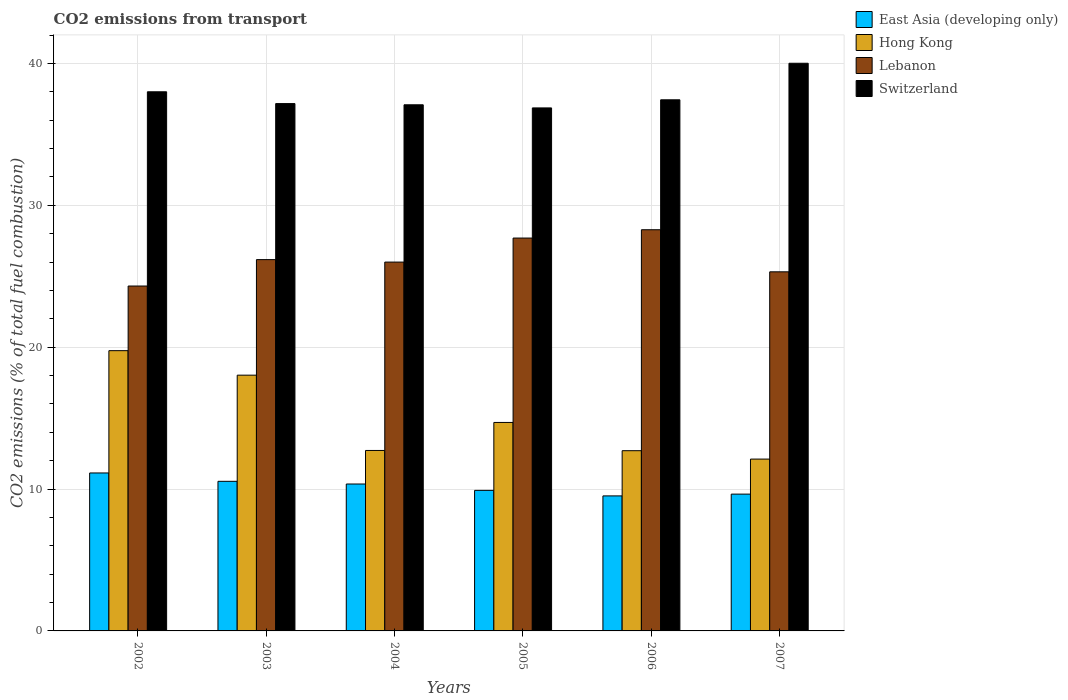How many different coloured bars are there?
Give a very brief answer. 4. How many groups of bars are there?
Offer a very short reply. 6. Are the number of bars on each tick of the X-axis equal?
Offer a very short reply. Yes. How many bars are there on the 5th tick from the left?
Offer a terse response. 4. In how many cases, is the number of bars for a given year not equal to the number of legend labels?
Offer a very short reply. 0. What is the total CO2 emitted in Hong Kong in 2002?
Your response must be concise. 19.75. Across all years, what is the maximum total CO2 emitted in Switzerland?
Make the answer very short. 40.01. Across all years, what is the minimum total CO2 emitted in Hong Kong?
Make the answer very short. 12.11. In which year was the total CO2 emitted in Lebanon minimum?
Provide a succinct answer. 2002. What is the total total CO2 emitted in Lebanon in the graph?
Make the answer very short. 157.77. What is the difference between the total CO2 emitted in Hong Kong in 2006 and that in 2007?
Give a very brief answer. 0.59. What is the difference between the total CO2 emitted in Hong Kong in 2003 and the total CO2 emitted in East Asia (developing only) in 2002?
Ensure brevity in your answer.  6.89. What is the average total CO2 emitted in Lebanon per year?
Provide a short and direct response. 26.29. In the year 2006, what is the difference between the total CO2 emitted in Lebanon and total CO2 emitted in Switzerland?
Offer a terse response. -9.16. What is the ratio of the total CO2 emitted in Hong Kong in 2003 to that in 2006?
Your response must be concise. 1.42. Is the total CO2 emitted in Switzerland in 2004 less than that in 2005?
Offer a terse response. No. What is the difference between the highest and the second highest total CO2 emitted in East Asia (developing only)?
Your response must be concise. 0.59. What is the difference between the highest and the lowest total CO2 emitted in East Asia (developing only)?
Make the answer very short. 1.62. In how many years, is the total CO2 emitted in Hong Kong greater than the average total CO2 emitted in Hong Kong taken over all years?
Your answer should be very brief. 2. Is the sum of the total CO2 emitted in Hong Kong in 2002 and 2005 greater than the maximum total CO2 emitted in East Asia (developing only) across all years?
Provide a succinct answer. Yes. Is it the case that in every year, the sum of the total CO2 emitted in Lebanon and total CO2 emitted in Switzerland is greater than the sum of total CO2 emitted in East Asia (developing only) and total CO2 emitted in Hong Kong?
Offer a terse response. No. What does the 2nd bar from the left in 2004 represents?
Provide a succinct answer. Hong Kong. What does the 1st bar from the right in 2003 represents?
Provide a succinct answer. Switzerland. How many bars are there?
Your response must be concise. 24. Are all the bars in the graph horizontal?
Make the answer very short. No. Are the values on the major ticks of Y-axis written in scientific E-notation?
Offer a terse response. No. Does the graph contain grids?
Give a very brief answer. Yes. What is the title of the graph?
Provide a succinct answer. CO2 emissions from transport. Does "Faeroe Islands" appear as one of the legend labels in the graph?
Make the answer very short. No. What is the label or title of the Y-axis?
Your answer should be very brief. CO2 emissions (% of total fuel combustion). What is the CO2 emissions (% of total fuel combustion) of East Asia (developing only) in 2002?
Keep it short and to the point. 11.13. What is the CO2 emissions (% of total fuel combustion) of Hong Kong in 2002?
Offer a terse response. 19.75. What is the CO2 emissions (% of total fuel combustion) in Lebanon in 2002?
Your response must be concise. 24.31. What is the CO2 emissions (% of total fuel combustion) of Switzerland in 2002?
Make the answer very short. 38. What is the CO2 emissions (% of total fuel combustion) in East Asia (developing only) in 2003?
Keep it short and to the point. 10.55. What is the CO2 emissions (% of total fuel combustion) of Hong Kong in 2003?
Provide a short and direct response. 18.03. What is the CO2 emissions (% of total fuel combustion) of Lebanon in 2003?
Ensure brevity in your answer.  26.17. What is the CO2 emissions (% of total fuel combustion) of Switzerland in 2003?
Make the answer very short. 37.17. What is the CO2 emissions (% of total fuel combustion) in East Asia (developing only) in 2004?
Give a very brief answer. 10.36. What is the CO2 emissions (% of total fuel combustion) of Hong Kong in 2004?
Your answer should be compact. 12.72. What is the CO2 emissions (% of total fuel combustion) in Lebanon in 2004?
Your response must be concise. 26. What is the CO2 emissions (% of total fuel combustion) of Switzerland in 2004?
Ensure brevity in your answer.  37.09. What is the CO2 emissions (% of total fuel combustion) of East Asia (developing only) in 2005?
Your answer should be compact. 9.91. What is the CO2 emissions (% of total fuel combustion) of Hong Kong in 2005?
Make the answer very short. 14.7. What is the CO2 emissions (% of total fuel combustion) of Lebanon in 2005?
Keep it short and to the point. 27.69. What is the CO2 emissions (% of total fuel combustion) in Switzerland in 2005?
Your answer should be compact. 36.87. What is the CO2 emissions (% of total fuel combustion) in East Asia (developing only) in 2006?
Give a very brief answer. 9.52. What is the CO2 emissions (% of total fuel combustion) in Hong Kong in 2006?
Keep it short and to the point. 12.7. What is the CO2 emissions (% of total fuel combustion) of Lebanon in 2006?
Provide a succinct answer. 28.28. What is the CO2 emissions (% of total fuel combustion) in Switzerland in 2006?
Provide a short and direct response. 37.44. What is the CO2 emissions (% of total fuel combustion) of East Asia (developing only) in 2007?
Make the answer very short. 9.64. What is the CO2 emissions (% of total fuel combustion) in Hong Kong in 2007?
Your answer should be very brief. 12.11. What is the CO2 emissions (% of total fuel combustion) in Lebanon in 2007?
Ensure brevity in your answer.  25.31. What is the CO2 emissions (% of total fuel combustion) of Switzerland in 2007?
Give a very brief answer. 40.01. Across all years, what is the maximum CO2 emissions (% of total fuel combustion) of East Asia (developing only)?
Offer a terse response. 11.13. Across all years, what is the maximum CO2 emissions (% of total fuel combustion) in Hong Kong?
Ensure brevity in your answer.  19.75. Across all years, what is the maximum CO2 emissions (% of total fuel combustion) in Lebanon?
Make the answer very short. 28.28. Across all years, what is the maximum CO2 emissions (% of total fuel combustion) in Switzerland?
Your response must be concise. 40.01. Across all years, what is the minimum CO2 emissions (% of total fuel combustion) in East Asia (developing only)?
Make the answer very short. 9.52. Across all years, what is the minimum CO2 emissions (% of total fuel combustion) of Hong Kong?
Your answer should be very brief. 12.11. Across all years, what is the minimum CO2 emissions (% of total fuel combustion) of Lebanon?
Your answer should be compact. 24.31. Across all years, what is the minimum CO2 emissions (% of total fuel combustion) in Switzerland?
Provide a short and direct response. 36.87. What is the total CO2 emissions (% of total fuel combustion) of East Asia (developing only) in the graph?
Make the answer very short. 61.1. What is the total CO2 emissions (% of total fuel combustion) in Hong Kong in the graph?
Offer a terse response. 90.02. What is the total CO2 emissions (% of total fuel combustion) of Lebanon in the graph?
Provide a short and direct response. 157.77. What is the total CO2 emissions (% of total fuel combustion) of Switzerland in the graph?
Offer a terse response. 226.58. What is the difference between the CO2 emissions (% of total fuel combustion) of East Asia (developing only) in 2002 and that in 2003?
Make the answer very short. 0.59. What is the difference between the CO2 emissions (% of total fuel combustion) in Hong Kong in 2002 and that in 2003?
Keep it short and to the point. 1.73. What is the difference between the CO2 emissions (% of total fuel combustion) in Lebanon in 2002 and that in 2003?
Make the answer very short. -1.86. What is the difference between the CO2 emissions (% of total fuel combustion) in Switzerland in 2002 and that in 2003?
Provide a succinct answer. 0.83. What is the difference between the CO2 emissions (% of total fuel combustion) of East Asia (developing only) in 2002 and that in 2004?
Provide a succinct answer. 0.78. What is the difference between the CO2 emissions (% of total fuel combustion) in Hong Kong in 2002 and that in 2004?
Your answer should be compact. 7.03. What is the difference between the CO2 emissions (% of total fuel combustion) of Lebanon in 2002 and that in 2004?
Your answer should be very brief. -1.69. What is the difference between the CO2 emissions (% of total fuel combustion) in Switzerland in 2002 and that in 2004?
Give a very brief answer. 0.92. What is the difference between the CO2 emissions (% of total fuel combustion) of East Asia (developing only) in 2002 and that in 2005?
Your response must be concise. 1.23. What is the difference between the CO2 emissions (% of total fuel combustion) of Hong Kong in 2002 and that in 2005?
Offer a terse response. 5.06. What is the difference between the CO2 emissions (% of total fuel combustion) in Lebanon in 2002 and that in 2005?
Your answer should be very brief. -3.38. What is the difference between the CO2 emissions (% of total fuel combustion) in Switzerland in 2002 and that in 2005?
Your answer should be compact. 1.14. What is the difference between the CO2 emissions (% of total fuel combustion) in East Asia (developing only) in 2002 and that in 2006?
Keep it short and to the point. 1.62. What is the difference between the CO2 emissions (% of total fuel combustion) in Hong Kong in 2002 and that in 2006?
Offer a terse response. 7.05. What is the difference between the CO2 emissions (% of total fuel combustion) in Lebanon in 2002 and that in 2006?
Provide a succinct answer. -3.97. What is the difference between the CO2 emissions (% of total fuel combustion) of Switzerland in 2002 and that in 2006?
Ensure brevity in your answer.  0.57. What is the difference between the CO2 emissions (% of total fuel combustion) in East Asia (developing only) in 2002 and that in 2007?
Your answer should be compact. 1.49. What is the difference between the CO2 emissions (% of total fuel combustion) in Hong Kong in 2002 and that in 2007?
Give a very brief answer. 7.64. What is the difference between the CO2 emissions (% of total fuel combustion) in Lebanon in 2002 and that in 2007?
Your answer should be very brief. -1. What is the difference between the CO2 emissions (% of total fuel combustion) of Switzerland in 2002 and that in 2007?
Make the answer very short. -2.01. What is the difference between the CO2 emissions (% of total fuel combustion) of East Asia (developing only) in 2003 and that in 2004?
Your response must be concise. 0.19. What is the difference between the CO2 emissions (% of total fuel combustion) in Hong Kong in 2003 and that in 2004?
Ensure brevity in your answer.  5.31. What is the difference between the CO2 emissions (% of total fuel combustion) of Lebanon in 2003 and that in 2004?
Offer a very short reply. 0.17. What is the difference between the CO2 emissions (% of total fuel combustion) in Switzerland in 2003 and that in 2004?
Ensure brevity in your answer.  0.09. What is the difference between the CO2 emissions (% of total fuel combustion) in East Asia (developing only) in 2003 and that in 2005?
Keep it short and to the point. 0.64. What is the difference between the CO2 emissions (% of total fuel combustion) in Hong Kong in 2003 and that in 2005?
Provide a succinct answer. 3.33. What is the difference between the CO2 emissions (% of total fuel combustion) in Lebanon in 2003 and that in 2005?
Your response must be concise. -1.52. What is the difference between the CO2 emissions (% of total fuel combustion) in Switzerland in 2003 and that in 2005?
Your answer should be very brief. 0.3. What is the difference between the CO2 emissions (% of total fuel combustion) of East Asia (developing only) in 2003 and that in 2006?
Give a very brief answer. 1.03. What is the difference between the CO2 emissions (% of total fuel combustion) of Hong Kong in 2003 and that in 2006?
Your answer should be very brief. 5.32. What is the difference between the CO2 emissions (% of total fuel combustion) of Lebanon in 2003 and that in 2006?
Offer a terse response. -2.11. What is the difference between the CO2 emissions (% of total fuel combustion) of Switzerland in 2003 and that in 2006?
Give a very brief answer. -0.27. What is the difference between the CO2 emissions (% of total fuel combustion) of East Asia (developing only) in 2003 and that in 2007?
Your response must be concise. 0.9. What is the difference between the CO2 emissions (% of total fuel combustion) in Hong Kong in 2003 and that in 2007?
Your response must be concise. 5.91. What is the difference between the CO2 emissions (% of total fuel combustion) in Lebanon in 2003 and that in 2007?
Offer a terse response. 0.86. What is the difference between the CO2 emissions (% of total fuel combustion) in Switzerland in 2003 and that in 2007?
Give a very brief answer. -2.84. What is the difference between the CO2 emissions (% of total fuel combustion) in East Asia (developing only) in 2004 and that in 2005?
Make the answer very short. 0.45. What is the difference between the CO2 emissions (% of total fuel combustion) of Hong Kong in 2004 and that in 2005?
Ensure brevity in your answer.  -1.97. What is the difference between the CO2 emissions (% of total fuel combustion) in Lebanon in 2004 and that in 2005?
Keep it short and to the point. -1.69. What is the difference between the CO2 emissions (% of total fuel combustion) of Switzerland in 2004 and that in 2005?
Provide a short and direct response. 0.22. What is the difference between the CO2 emissions (% of total fuel combustion) of East Asia (developing only) in 2004 and that in 2006?
Ensure brevity in your answer.  0.84. What is the difference between the CO2 emissions (% of total fuel combustion) in Hong Kong in 2004 and that in 2006?
Your answer should be compact. 0.02. What is the difference between the CO2 emissions (% of total fuel combustion) of Lebanon in 2004 and that in 2006?
Offer a terse response. -2.28. What is the difference between the CO2 emissions (% of total fuel combustion) of Switzerland in 2004 and that in 2006?
Make the answer very short. -0.35. What is the difference between the CO2 emissions (% of total fuel combustion) of East Asia (developing only) in 2004 and that in 2007?
Keep it short and to the point. 0.71. What is the difference between the CO2 emissions (% of total fuel combustion) in Hong Kong in 2004 and that in 2007?
Your response must be concise. 0.61. What is the difference between the CO2 emissions (% of total fuel combustion) of Lebanon in 2004 and that in 2007?
Your answer should be very brief. 0.69. What is the difference between the CO2 emissions (% of total fuel combustion) in Switzerland in 2004 and that in 2007?
Ensure brevity in your answer.  -2.93. What is the difference between the CO2 emissions (% of total fuel combustion) in East Asia (developing only) in 2005 and that in 2006?
Make the answer very short. 0.39. What is the difference between the CO2 emissions (% of total fuel combustion) in Hong Kong in 2005 and that in 2006?
Your answer should be compact. 1.99. What is the difference between the CO2 emissions (% of total fuel combustion) in Lebanon in 2005 and that in 2006?
Provide a succinct answer. -0.58. What is the difference between the CO2 emissions (% of total fuel combustion) of Switzerland in 2005 and that in 2006?
Your answer should be compact. -0.57. What is the difference between the CO2 emissions (% of total fuel combustion) of East Asia (developing only) in 2005 and that in 2007?
Your response must be concise. 0.26. What is the difference between the CO2 emissions (% of total fuel combustion) in Hong Kong in 2005 and that in 2007?
Make the answer very short. 2.58. What is the difference between the CO2 emissions (% of total fuel combustion) of Lebanon in 2005 and that in 2007?
Your answer should be compact. 2.38. What is the difference between the CO2 emissions (% of total fuel combustion) of Switzerland in 2005 and that in 2007?
Give a very brief answer. -3.15. What is the difference between the CO2 emissions (% of total fuel combustion) in East Asia (developing only) in 2006 and that in 2007?
Your response must be concise. -0.13. What is the difference between the CO2 emissions (% of total fuel combustion) of Hong Kong in 2006 and that in 2007?
Make the answer very short. 0.59. What is the difference between the CO2 emissions (% of total fuel combustion) in Lebanon in 2006 and that in 2007?
Your answer should be very brief. 2.97. What is the difference between the CO2 emissions (% of total fuel combustion) in Switzerland in 2006 and that in 2007?
Ensure brevity in your answer.  -2.58. What is the difference between the CO2 emissions (% of total fuel combustion) of East Asia (developing only) in 2002 and the CO2 emissions (% of total fuel combustion) of Hong Kong in 2003?
Your answer should be compact. -6.89. What is the difference between the CO2 emissions (% of total fuel combustion) of East Asia (developing only) in 2002 and the CO2 emissions (% of total fuel combustion) of Lebanon in 2003?
Your answer should be compact. -15.04. What is the difference between the CO2 emissions (% of total fuel combustion) of East Asia (developing only) in 2002 and the CO2 emissions (% of total fuel combustion) of Switzerland in 2003?
Keep it short and to the point. -26.04. What is the difference between the CO2 emissions (% of total fuel combustion) of Hong Kong in 2002 and the CO2 emissions (% of total fuel combustion) of Lebanon in 2003?
Your response must be concise. -6.42. What is the difference between the CO2 emissions (% of total fuel combustion) of Hong Kong in 2002 and the CO2 emissions (% of total fuel combustion) of Switzerland in 2003?
Provide a succinct answer. -17.42. What is the difference between the CO2 emissions (% of total fuel combustion) in Lebanon in 2002 and the CO2 emissions (% of total fuel combustion) in Switzerland in 2003?
Your answer should be very brief. -12.86. What is the difference between the CO2 emissions (% of total fuel combustion) in East Asia (developing only) in 2002 and the CO2 emissions (% of total fuel combustion) in Hong Kong in 2004?
Keep it short and to the point. -1.59. What is the difference between the CO2 emissions (% of total fuel combustion) of East Asia (developing only) in 2002 and the CO2 emissions (% of total fuel combustion) of Lebanon in 2004?
Your answer should be compact. -14.86. What is the difference between the CO2 emissions (% of total fuel combustion) of East Asia (developing only) in 2002 and the CO2 emissions (% of total fuel combustion) of Switzerland in 2004?
Make the answer very short. -25.95. What is the difference between the CO2 emissions (% of total fuel combustion) in Hong Kong in 2002 and the CO2 emissions (% of total fuel combustion) in Lebanon in 2004?
Offer a very short reply. -6.24. What is the difference between the CO2 emissions (% of total fuel combustion) in Hong Kong in 2002 and the CO2 emissions (% of total fuel combustion) in Switzerland in 2004?
Your response must be concise. -17.33. What is the difference between the CO2 emissions (% of total fuel combustion) of Lebanon in 2002 and the CO2 emissions (% of total fuel combustion) of Switzerland in 2004?
Ensure brevity in your answer.  -12.77. What is the difference between the CO2 emissions (% of total fuel combustion) of East Asia (developing only) in 2002 and the CO2 emissions (% of total fuel combustion) of Hong Kong in 2005?
Provide a short and direct response. -3.56. What is the difference between the CO2 emissions (% of total fuel combustion) of East Asia (developing only) in 2002 and the CO2 emissions (% of total fuel combustion) of Lebanon in 2005?
Provide a short and direct response. -16.56. What is the difference between the CO2 emissions (% of total fuel combustion) in East Asia (developing only) in 2002 and the CO2 emissions (% of total fuel combustion) in Switzerland in 2005?
Keep it short and to the point. -25.73. What is the difference between the CO2 emissions (% of total fuel combustion) in Hong Kong in 2002 and the CO2 emissions (% of total fuel combustion) in Lebanon in 2005?
Provide a short and direct response. -7.94. What is the difference between the CO2 emissions (% of total fuel combustion) in Hong Kong in 2002 and the CO2 emissions (% of total fuel combustion) in Switzerland in 2005?
Give a very brief answer. -17.11. What is the difference between the CO2 emissions (% of total fuel combustion) in Lebanon in 2002 and the CO2 emissions (% of total fuel combustion) in Switzerland in 2005?
Provide a short and direct response. -12.55. What is the difference between the CO2 emissions (% of total fuel combustion) in East Asia (developing only) in 2002 and the CO2 emissions (% of total fuel combustion) in Hong Kong in 2006?
Provide a succinct answer. -1.57. What is the difference between the CO2 emissions (% of total fuel combustion) of East Asia (developing only) in 2002 and the CO2 emissions (% of total fuel combustion) of Lebanon in 2006?
Make the answer very short. -17.14. What is the difference between the CO2 emissions (% of total fuel combustion) of East Asia (developing only) in 2002 and the CO2 emissions (% of total fuel combustion) of Switzerland in 2006?
Provide a short and direct response. -26.3. What is the difference between the CO2 emissions (% of total fuel combustion) of Hong Kong in 2002 and the CO2 emissions (% of total fuel combustion) of Lebanon in 2006?
Provide a short and direct response. -8.52. What is the difference between the CO2 emissions (% of total fuel combustion) in Hong Kong in 2002 and the CO2 emissions (% of total fuel combustion) in Switzerland in 2006?
Make the answer very short. -17.68. What is the difference between the CO2 emissions (% of total fuel combustion) in Lebanon in 2002 and the CO2 emissions (% of total fuel combustion) in Switzerland in 2006?
Offer a very short reply. -13.13. What is the difference between the CO2 emissions (% of total fuel combustion) of East Asia (developing only) in 2002 and the CO2 emissions (% of total fuel combustion) of Hong Kong in 2007?
Provide a succinct answer. -0.98. What is the difference between the CO2 emissions (% of total fuel combustion) in East Asia (developing only) in 2002 and the CO2 emissions (% of total fuel combustion) in Lebanon in 2007?
Keep it short and to the point. -14.18. What is the difference between the CO2 emissions (% of total fuel combustion) of East Asia (developing only) in 2002 and the CO2 emissions (% of total fuel combustion) of Switzerland in 2007?
Your answer should be very brief. -28.88. What is the difference between the CO2 emissions (% of total fuel combustion) of Hong Kong in 2002 and the CO2 emissions (% of total fuel combustion) of Lebanon in 2007?
Offer a very short reply. -5.56. What is the difference between the CO2 emissions (% of total fuel combustion) of Hong Kong in 2002 and the CO2 emissions (% of total fuel combustion) of Switzerland in 2007?
Your response must be concise. -20.26. What is the difference between the CO2 emissions (% of total fuel combustion) of Lebanon in 2002 and the CO2 emissions (% of total fuel combustion) of Switzerland in 2007?
Your response must be concise. -15.7. What is the difference between the CO2 emissions (% of total fuel combustion) of East Asia (developing only) in 2003 and the CO2 emissions (% of total fuel combustion) of Hong Kong in 2004?
Your answer should be very brief. -2.18. What is the difference between the CO2 emissions (% of total fuel combustion) of East Asia (developing only) in 2003 and the CO2 emissions (% of total fuel combustion) of Lebanon in 2004?
Provide a short and direct response. -15.45. What is the difference between the CO2 emissions (% of total fuel combustion) in East Asia (developing only) in 2003 and the CO2 emissions (% of total fuel combustion) in Switzerland in 2004?
Give a very brief answer. -26.54. What is the difference between the CO2 emissions (% of total fuel combustion) of Hong Kong in 2003 and the CO2 emissions (% of total fuel combustion) of Lebanon in 2004?
Provide a succinct answer. -7.97. What is the difference between the CO2 emissions (% of total fuel combustion) of Hong Kong in 2003 and the CO2 emissions (% of total fuel combustion) of Switzerland in 2004?
Your answer should be compact. -19.06. What is the difference between the CO2 emissions (% of total fuel combustion) of Lebanon in 2003 and the CO2 emissions (% of total fuel combustion) of Switzerland in 2004?
Keep it short and to the point. -10.91. What is the difference between the CO2 emissions (% of total fuel combustion) in East Asia (developing only) in 2003 and the CO2 emissions (% of total fuel combustion) in Hong Kong in 2005?
Make the answer very short. -4.15. What is the difference between the CO2 emissions (% of total fuel combustion) in East Asia (developing only) in 2003 and the CO2 emissions (% of total fuel combustion) in Lebanon in 2005?
Provide a succinct answer. -17.15. What is the difference between the CO2 emissions (% of total fuel combustion) in East Asia (developing only) in 2003 and the CO2 emissions (% of total fuel combustion) in Switzerland in 2005?
Offer a very short reply. -26.32. What is the difference between the CO2 emissions (% of total fuel combustion) in Hong Kong in 2003 and the CO2 emissions (% of total fuel combustion) in Lebanon in 2005?
Give a very brief answer. -9.67. What is the difference between the CO2 emissions (% of total fuel combustion) in Hong Kong in 2003 and the CO2 emissions (% of total fuel combustion) in Switzerland in 2005?
Offer a terse response. -18.84. What is the difference between the CO2 emissions (% of total fuel combustion) in Lebanon in 2003 and the CO2 emissions (% of total fuel combustion) in Switzerland in 2005?
Give a very brief answer. -10.69. What is the difference between the CO2 emissions (% of total fuel combustion) of East Asia (developing only) in 2003 and the CO2 emissions (% of total fuel combustion) of Hong Kong in 2006?
Your response must be concise. -2.16. What is the difference between the CO2 emissions (% of total fuel combustion) of East Asia (developing only) in 2003 and the CO2 emissions (% of total fuel combustion) of Lebanon in 2006?
Your answer should be compact. -17.73. What is the difference between the CO2 emissions (% of total fuel combustion) of East Asia (developing only) in 2003 and the CO2 emissions (% of total fuel combustion) of Switzerland in 2006?
Offer a very short reply. -26.89. What is the difference between the CO2 emissions (% of total fuel combustion) in Hong Kong in 2003 and the CO2 emissions (% of total fuel combustion) in Lebanon in 2006?
Offer a very short reply. -10.25. What is the difference between the CO2 emissions (% of total fuel combustion) in Hong Kong in 2003 and the CO2 emissions (% of total fuel combustion) in Switzerland in 2006?
Make the answer very short. -19.41. What is the difference between the CO2 emissions (% of total fuel combustion) of Lebanon in 2003 and the CO2 emissions (% of total fuel combustion) of Switzerland in 2006?
Your response must be concise. -11.26. What is the difference between the CO2 emissions (% of total fuel combustion) in East Asia (developing only) in 2003 and the CO2 emissions (% of total fuel combustion) in Hong Kong in 2007?
Make the answer very short. -1.57. What is the difference between the CO2 emissions (% of total fuel combustion) in East Asia (developing only) in 2003 and the CO2 emissions (% of total fuel combustion) in Lebanon in 2007?
Give a very brief answer. -14.77. What is the difference between the CO2 emissions (% of total fuel combustion) of East Asia (developing only) in 2003 and the CO2 emissions (% of total fuel combustion) of Switzerland in 2007?
Provide a succinct answer. -29.47. What is the difference between the CO2 emissions (% of total fuel combustion) in Hong Kong in 2003 and the CO2 emissions (% of total fuel combustion) in Lebanon in 2007?
Your answer should be very brief. -7.28. What is the difference between the CO2 emissions (% of total fuel combustion) in Hong Kong in 2003 and the CO2 emissions (% of total fuel combustion) in Switzerland in 2007?
Your answer should be very brief. -21.99. What is the difference between the CO2 emissions (% of total fuel combustion) of Lebanon in 2003 and the CO2 emissions (% of total fuel combustion) of Switzerland in 2007?
Offer a terse response. -13.84. What is the difference between the CO2 emissions (% of total fuel combustion) in East Asia (developing only) in 2004 and the CO2 emissions (% of total fuel combustion) in Hong Kong in 2005?
Offer a terse response. -4.34. What is the difference between the CO2 emissions (% of total fuel combustion) of East Asia (developing only) in 2004 and the CO2 emissions (% of total fuel combustion) of Lebanon in 2005?
Offer a terse response. -17.34. What is the difference between the CO2 emissions (% of total fuel combustion) in East Asia (developing only) in 2004 and the CO2 emissions (% of total fuel combustion) in Switzerland in 2005?
Offer a very short reply. -26.51. What is the difference between the CO2 emissions (% of total fuel combustion) in Hong Kong in 2004 and the CO2 emissions (% of total fuel combustion) in Lebanon in 2005?
Your answer should be compact. -14.97. What is the difference between the CO2 emissions (% of total fuel combustion) of Hong Kong in 2004 and the CO2 emissions (% of total fuel combustion) of Switzerland in 2005?
Your response must be concise. -24.15. What is the difference between the CO2 emissions (% of total fuel combustion) in Lebanon in 2004 and the CO2 emissions (% of total fuel combustion) in Switzerland in 2005?
Ensure brevity in your answer.  -10.87. What is the difference between the CO2 emissions (% of total fuel combustion) of East Asia (developing only) in 2004 and the CO2 emissions (% of total fuel combustion) of Hong Kong in 2006?
Your answer should be very brief. -2.35. What is the difference between the CO2 emissions (% of total fuel combustion) of East Asia (developing only) in 2004 and the CO2 emissions (% of total fuel combustion) of Lebanon in 2006?
Make the answer very short. -17.92. What is the difference between the CO2 emissions (% of total fuel combustion) of East Asia (developing only) in 2004 and the CO2 emissions (% of total fuel combustion) of Switzerland in 2006?
Offer a terse response. -27.08. What is the difference between the CO2 emissions (% of total fuel combustion) in Hong Kong in 2004 and the CO2 emissions (% of total fuel combustion) in Lebanon in 2006?
Provide a short and direct response. -15.56. What is the difference between the CO2 emissions (% of total fuel combustion) in Hong Kong in 2004 and the CO2 emissions (% of total fuel combustion) in Switzerland in 2006?
Offer a terse response. -24.72. What is the difference between the CO2 emissions (% of total fuel combustion) in Lebanon in 2004 and the CO2 emissions (% of total fuel combustion) in Switzerland in 2006?
Provide a short and direct response. -11.44. What is the difference between the CO2 emissions (% of total fuel combustion) of East Asia (developing only) in 2004 and the CO2 emissions (% of total fuel combustion) of Hong Kong in 2007?
Offer a terse response. -1.76. What is the difference between the CO2 emissions (% of total fuel combustion) in East Asia (developing only) in 2004 and the CO2 emissions (% of total fuel combustion) in Lebanon in 2007?
Give a very brief answer. -14.96. What is the difference between the CO2 emissions (% of total fuel combustion) in East Asia (developing only) in 2004 and the CO2 emissions (% of total fuel combustion) in Switzerland in 2007?
Your answer should be compact. -29.66. What is the difference between the CO2 emissions (% of total fuel combustion) of Hong Kong in 2004 and the CO2 emissions (% of total fuel combustion) of Lebanon in 2007?
Make the answer very short. -12.59. What is the difference between the CO2 emissions (% of total fuel combustion) of Hong Kong in 2004 and the CO2 emissions (% of total fuel combustion) of Switzerland in 2007?
Your response must be concise. -27.29. What is the difference between the CO2 emissions (% of total fuel combustion) in Lebanon in 2004 and the CO2 emissions (% of total fuel combustion) in Switzerland in 2007?
Provide a succinct answer. -14.02. What is the difference between the CO2 emissions (% of total fuel combustion) of East Asia (developing only) in 2005 and the CO2 emissions (% of total fuel combustion) of Hong Kong in 2006?
Offer a very short reply. -2.8. What is the difference between the CO2 emissions (% of total fuel combustion) of East Asia (developing only) in 2005 and the CO2 emissions (% of total fuel combustion) of Lebanon in 2006?
Make the answer very short. -18.37. What is the difference between the CO2 emissions (% of total fuel combustion) in East Asia (developing only) in 2005 and the CO2 emissions (% of total fuel combustion) in Switzerland in 2006?
Offer a terse response. -27.53. What is the difference between the CO2 emissions (% of total fuel combustion) of Hong Kong in 2005 and the CO2 emissions (% of total fuel combustion) of Lebanon in 2006?
Your answer should be very brief. -13.58. What is the difference between the CO2 emissions (% of total fuel combustion) in Hong Kong in 2005 and the CO2 emissions (% of total fuel combustion) in Switzerland in 2006?
Provide a succinct answer. -22.74. What is the difference between the CO2 emissions (% of total fuel combustion) in Lebanon in 2005 and the CO2 emissions (% of total fuel combustion) in Switzerland in 2006?
Keep it short and to the point. -9.74. What is the difference between the CO2 emissions (% of total fuel combustion) in East Asia (developing only) in 2005 and the CO2 emissions (% of total fuel combustion) in Hong Kong in 2007?
Provide a short and direct response. -2.21. What is the difference between the CO2 emissions (% of total fuel combustion) of East Asia (developing only) in 2005 and the CO2 emissions (% of total fuel combustion) of Lebanon in 2007?
Your response must be concise. -15.4. What is the difference between the CO2 emissions (% of total fuel combustion) of East Asia (developing only) in 2005 and the CO2 emissions (% of total fuel combustion) of Switzerland in 2007?
Ensure brevity in your answer.  -30.11. What is the difference between the CO2 emissions (% of total fuel combustion) of Hong Kong in 2005 and the CO2 emissions (% of total fuel combustion) of Lebanon in 2007?
Provide a succinct answer. -10.62. What is the difference between the CO2 emissions (% of total fuel combustion) of Hong Kong in 2005 and the CO2 emissions (% of total fuel combustion) of Switzerland in 2007?
Give a very brief answer. -25.32. What is the difference between the CO2 emissions (% of total fuel combustion) in Lebanon in 2005 and the CO2 emissions (% of total fuel combustion) in Switzerland in 2007?
Make the answer very short. -12.32. What is the difference between the CO2 emissions (% of total fuel combustion) of East Asia (developing only) in 2006 and the CO2 emissions (% of total fuel combustion) of Hong Kong in 2007?
Make the answer very short. -2.6. What is the difference between the CO2 emissions (% of total fuel combustion) in East Asia (developing only) in 2006 and the CO2 emissions (% of total fuel combustion) in Lebanon in 2007?
Ensure brevity in your answer.  -15.79. What is the difference between the CO2 emissions (% of total fuel combustion) of East Asia (developing only) in 2006 and the CO2 emissions (% of total fuel combustion) of Switzerland in 2007?
Your answer should be very brief. -30.5. What is the difference between the CO2 emissions (% of total fuel combustion) in Hong Kong in 2006 and the CO2 emissions (% of total fuel combustion) in Lebanon in 2007?
Keep it short and to the point. -12.61. What is the difference between the CO2 emissions (% of total fuel combustion) of Hong Kong in 2006 and the CO2 emissions (% of total fuel combustion) of Switzerland in 2007?
Offer a terse response. -27.31. What is the difference between the CO2 emissions (% of total fuel combustion) in Lebanon in 2006 and the CO2 emissions (% of total fuel combustion) in Switzerland in 2007?
Your response must be concise. -11.74. What is the average CO2 emissions (% of total fuel combustion) of East Asia (developing only) per year?
Offer a very short reply. 10.18. What is the average CO2 emissions (% of total fuel combustion) of Hong Kong per year?
Your response must be concise. 15. What is the average CO2 emissions (% of total fuel combustion) in Lebanon per year?
Provide a succinct answer. 26.29. What is the average CO2 emissions (% of total fuel combustion) of Switzerland per year?
Your answer should be compact. 37.76. In the year 2002, what is the difference between the CO2 emissions (% of total fuel combustion) in East Asia (developing only) and CO2 emissions (% of total fuel combustion) in Hong Kong?
Provide a short and direct response. -8.62. In the year 2002, what is the difference between the CO2 emissions (% of total fuel combustion) in East Asia (developing only) and CO2 emissions (% of total fuel combustion) in Lebanon?
Offer a very short reply. -13.18. In the year 2002, what is the difference between the CO2 emissions (% of total fuel combustion) of East Asia (developing only) and CO2 emissions (% of total fuel combustion) of Switzerland?
Your answer should be compact. -26.87. In the year 2002, what is the difference between the CO2 emissions (% of total fuel combustion) in Hong Kong and CO2 emissions (% of total fuel combustion) in Lebanon?
Your answer should be compact. -4.56. In the year 2002, what is the difference between the CO2 emissions (% of total fuel combustion) of Hong Kong and CO2 emissions (% of total fuel combustion) of Switzerland?
Provide a succinct answer. -18.25. In the year 2002, what is the difference between the CO2 emissions (% of total fuel combustion) in Lebanon and CO2 emissions (% of total fuel combustion) in Switzerland?
Keep it short and to the point. -13.69. In the year 2003, what is the difference between the CO2 emissions (% of total fuel combustion) of East Asia (developing only) and CO2 emissions (% of total fuel combustion) of Hong Kong?
Your answer should be very brief. -7.48. In the year 2003, what is the difference between the CO2 emissions (% of total fuel combustion) of East Asia (developing only) and CO2 emissions (% of total fuel combustion) of Lebanon?
Keep it short and to the point. -15.63. In the year 2003, what is the difference between the CO2 emissions (% of total fuel combustion) of East Asia (developing only) and CO2 emissions (% of total fuel combustion) of Switzerland?
Give a very brief answer. -26.63. In the year 2003, what is the difference between the CO2 emissions (% of total fuel combustion) in Hong Kong and CO2 emissions (% of total fuel combustion) in Lebanon?
Offer a terse response. -8.15. In the year 2003, what is the difference between the CO2 emissions (% of total fuel combustion) of Hong Kong and CO2 emissions (% of total fuel combustion) of Switzerland?
Offer a very short reply. -19.14. In the year 2003, what is the difference between the CO2 emissions (% of total fuel combustion) of Lebanon and CO2 emissions (% of total fuel combustion) of Switzerland?
Provide a short and direct response. -11. In the year 2004, what is the difference between the CO2 emissions (% of total fuel combustion) of East Asia (developing only) and CO2 emissions (% of total fuel combustion) of Hong Kong?
Provide a short and direct response. -2.36. In the year 2004, what is the difference between the CO2 emissions (% of total fuel combustion) in East Asia (developing only) and CO2 emissions (% of total fuel combustion) in Lebanon?
Offer a terse response. -15.64. In the year 2004, what is the difference between the CO2 emissions (% of total fuel combustion) of East Asia (developing only) and CO2 emissions (% of total fuel combustion) of Switzerland?
Your answer should be very brief. -26.73. In the year 2004, what is the difference between the CO2 emissions (% of total fuel combustion) of Hong Kong and CO2 emissions (% of total fuel combustion) of Lebanon?
Offer a very short reply. -13.28. In the year 2004, what is the difference between the CO2 emissions (% of total fuel combustion) in Hong Kong and CO2 emissions (% of total fuel combustion) in Switzerland?
Provide a succinct answer. -24.37. In the year 2004, what is the difference between the CO2 emissions (% of total fuel combustion) of Lebanon and CO2 emissions (% of total fuel combustion) of Switzerland?
Provide a short and direct response. -11.09. In the year 2005, what is the difference between the CO2 emissions (% of total fuel combustion) of East Asia (developing only) and CO2 emissions (% of total fuel combustion) of Hong Kong?
Ensure brevity in your answer.  -4.79. In the year 2005, what is the difference between the CO2 emissions (% of total fuel combustion) of East Asia (developing only) and CO2 emissions (% of total fuel combustion) of Lebanon?
Keep it short and to the point. -17.79. In the year 2005, what is the difference between the CO2 emissions (% of total fuel combustion) of East Asia (developing only) and CO2 emissions (% of total fuel combustion) of Switzerland?
Your answer should be very brief. -26.96. In the year 2005, what is the difference between the CO2 emissions (% of total fuel combustion) of Hong Kong and CO2 emissions (% of total fuel combustion) of Lebanon?
Make the answer very short. -13. In the year 2005, what is the difference between the CO2 emissions (% of total fuel combustion) of Hong Kong and CO2 emissions (% of total fuel combustion) of Switzerland?
Your answer should be very brief. -22.17. In the year 2005, what is the difference between the CO2 emissions (% of total fuel combustion) of Lebanon and CO2 emissions (% of total fuel combustion) of Switzerland?
Your response must be concise. -9.17. In the year 2006, what is the difference between the CO2 emissions (% of total fuel combustion) of East Asia (developing only) and CO2 emissions (% of total fuel combustion) of Hong Kong?
Provide a succinct answer. -3.19. In the year 2006, what is the difference between the CO2 emissions (% of total fuel combustion) of East Asia (developing only) and CO2 emissions (% of total fuel combustion) of Lebanon?
Make the answer very short. -18.76. In the year 2006, what is the difference between the CO2 emissions (% of total fuel combustion) of East Asia (developing only) and CO2 emissions (% of total fuel combustion) of Switzerland?
Give a very brief answer. -27.92. In the year 2006, what is the difference between the CO2 emissions (% of total fuel combustion) of Hong Kong and CO2 emissions (% of total fuel combustion) of Lebanon?
Provide a short and direct response. -15.57. In the year 2006, what is the difference between the CO2 emissions (% of total fuel combustion) in Hong Kong and CO2 emissions (% of total fuel combustion) in Switzerland?
Make the answer very short. -24.73. In the year 2006, what is the difference between the CO2 emissions (% of total fuel combustion) in Lebanon and CO2 emissions (% of total fuel combustion) in Switzerland?
Make the answer very short. -9.16. In the year 2007, what is the difference between the CO2 emissions (% of total fuel combustion) of East Asia (developing only) and CO2 emissions (% of total fuel combustion) of Hong Kong?
Your answer should be very brief. -2.47. In the year 2007, what is the difference between the CO2 emissions (% of total fuel combustion) in East Asia (developing only) and CO2 emissions (% of total fuel combustion) in Lebanon?
Give a very brief answer. -15.67. In the year 2007, what is the difference between the CO2 emissions (% of total fuel combustion) in East Asia (developing only) and CO2 emissions (% of total fuel combustion) in Switzerland?
Your response must be concise. -30.37. In the year 2007, what is the difference between the CO2 emissions (% of total fuel combustion) in Hong Kong and CO2 emissions (% of total fuel combustion) in Lebanon?
Ensure brevity in your answer.  -13.2. In the year 2007, what is the difference between the CO2 emissions (% of total fuel combustion) in Hong Kong and CO2 emissions (% of total fuel combustion) in Switzerland?
Provide a short and direct response. -27.9. In the year 2007, what is the difference between the CO2 emissions (% of total fuel combustion) in Lebanon and CO2 emissions (% of total fuel combustion) in Switzerland?
Provide a short and direct response. -14.7. What is the ratio of the CO2 emissions (% of total fuel combustion) in East Asia (developing only) in 2002 to that in 2003?
Provide a succinct answer. 1.06. What is the ratio of the CO2 emissions (% of total fuel combustion) in Hong Kong in 2002 to that in 2003?
Your response must be concise. 1.1. What is the ratio of the CO2 emissions (% of total fuel combustion) in Lebanon in 2002 to that in 2003?
Ensure brevity in your answer.  0.93. What is the ratio of the CO2 emissions (% of total fuel combustion) of Switzerland in 2002 to that in 2003?
Your response must be concise. 1.02. What is the ratio of the CO2 emissions (% of total fuel combustion) in East Asia (developing only) in 2002 to that in 2004?
Your answer should be very brief. 1.08. What is the ratio of the CO2 emissions (% of total fuel combustion) of Hong Kong in 2002 to that in 2004?
Keep it short and to the point. 1.55. What is the ratio of the CO2 emissions (% of total fuel combustion) in Lebanon in 2002 to that in 2004?
Make the answer very short. 0.94. What is the ratio of the CO2 emissions (% of total fuel combustion) of Switzerland in 2002 to that in 2004?
Offer a very short reply. 1.02. What is the ratio of the CO2 emissions (% of total fuel combustion) in East Asia (developing only) in 2002 to that in 2005?
Your answer should be very brief. 1.12. What is the ratio of the CO2 emissions (% of total fuel combustion) in Hong Kong in 2002 to that in 2005?
Keep it short and to the point. 1.34. What is the ratio of the CO2 emissions (% of total fuel combustion) of Lebanon in 2002 to that in 2005?
Your response must be concise. 0.88. What is the ratio of the CO2 emissions (% of total fuel combustion) of Switzerland in 2002 to that in 2005?
Make the answer very short. 1.03. What is the ratio of the CO2 emissions (% of total fuel combustion) in East Asia (developing only) in 2002 to that in 2006?
Provide a short and direct response. 1.17. What is the ratio of the CO2 emissions (% of total fuel combustion) in Hong Kong in 2002 to that in 2006?
Provide a short and direct response. 1.55. What is the ratio of the CO2 emissions (% of total fuel combustion) in Lebanon in 2002 to that in 2006?
Provide a succinct answer. 0.86. What is the ratio of the CO2 emissions (% of total fuel combustion) of Switzerland in 2002 to that in 2006?
Offer a very short reply. 1.02. What is the ratio of the CO2 emissions (% of total fuel combustion) in East Asia (developing only) in 2002 to that in 2007?
Offer a terse response. 1.15. What is the ratio of the CO2 emissions (% of total fuel combustion) of Hong Kong in 2002 to that in 2007?
Keep it short and to the point. 1.63. What is the ratio of the CO2 emissions (% of total fuel combustion) of Lebanon in 2002 to that in 2007?
Ensure brevity in your answer.  0.96. What is the ratio of the CO2 emissions (% of total fuel combustion) in Switzerland in 2002 to that in 2007?
Make the answer very short. 0.95. What is the ratio of the CO2 emissions (% of total fuel combustion) of East Asia (developing only) in 2003 to that in 2004?
Ensure brevity in your answer.  1.02. What is the ratio of the CO2 emissions (% of total fuel combustion) in Hong Kong in 2003 to that in 2004?
Provide a short and direct response. 1.42. What is the ratio of the CO2 emissions (% of total fuel combustion) in East Asia (developing only) in 2003 to that in 2005?
Provide a short and direct response. 1.06. What is the ratio of the CO2 emissions (% of total fuel combustion) of Hong Kong in 2003 to that in 2005?
Your answer should be compact. 1.23. What is the ratio of the CO2 emissions (% of total fuel combustion) of Lebanon in 2003 to that in 2005?
Your response must be concise. 0.95. What is the ratio of the CO2 emissions (% of total fuel combustion) of Switzerland in 2003 to that in 2005?
Offer a terse response. 1.01. What is the ratio of the CO2 emissions (% of total fuel combustion) of East Asia (developing only) in 2003 to that in 2006?
Provide a succinct answer. 1.11. What is the ratio of the CO2 emissions (% of total fuel combustion) in Hong Kong in 2003 to that in 2006?
Make the answer very short. 1.42. What is the ratio of the CO2 emissions (% of total fuel combustion) of Lebanon in 2003 to that in 2006?
Provide a succinct answer. 0.93. What is the ratio of the CO2 emissions (% of total fuel combustion) of East Asia (developing only) in 2003 to that in 2007?
Provide a succinct answer. 1.09. What is the ratio of the CO2 emissions (% of total fuel combustion) of Hong Kong in 2003 to that in 2007?
Provide a succinct answer. 1.49. What is the ratio of the CO2 emissions (% of total fuel combustion) of Lebanon in 2003 to that in 2007?
Offer a very short reply. 1.03. What is the ratio of the CO2 emissions (% of total fuel combustion) in Switzerland in 2003 to that in 2007?
Keep it short and to the point. 0.93. What is the ratio of the CO2 emissions (% of total fuel combustion) of East Asia (developing only) in 2004 to that in 2005?
Make the answer very short. 1.05. What is the ratio of the CO2 emissions (% of total fuel combustion) in Hong Kong in 2004 to that in 2005?
Offer a terse response. 0.87. What is the ratio of the CO2 emissions (% of total fuel combustion) of Lebanon in 2004 to that in 2005?
Make the answer very short. 0.94. What is the ratio of the CO2 emissions (% of total fuel combustion) of Switzerland in 2004 to that in 2005?
Your answer should be very brief. 1.01. What is the ratio of the CO2 emissions (% of total fuel combustion) in East Asia (developing only) in 2004 to that in 2006?
Give a very brief answer. 1.09. What is the ratio of the CO2 emissions (% of total fuel combustion) of Lebanon in 2004 to that in 2006?
Your answer should be very brief. 0.92. What is the ratio of the CO2 emissions (% of total fuel combustion) in Switzerland in 2004 to that in 2006?
Provide a short and direct response. 0.99. What is the ratio of the CO2 emissions (% of total fuel combustion) of East Asia (developing only) in 2004 to that in 2007?
Provide a succinct answer. 1.07. What is the ratio of the CO2 emissions (% of total fuel combustion) of Hong Kong in 2004 to that in 2007?
Your response must be concise. 1.05. What is the ratio of the CO2 emissions (% of total fuel combustion) in Lebanon in 2004 to that in 2007?
Give a very brief answer. 1.03. What is the ratio of the CO2 emissions (% of total fuel combustion) of Switzerland in 2004 to that in 2007?
Ensure brevity in your answer.  0.93. What is the ratio of the CO2 emissions (% of total fuel combustion) of East Asia (developing only) in 2005 to that in 2006?
Offer a terse response. 1.04. What is the ratio of the CO2 emissions (% of total fuel combustion) of Hong Kong in 2005 to that in 2006?
Offer a terse response. 1.16. What is the ratio of the CO2 emissions (% of total fuel combustion) of Lebanon in 2005 to that in 2006?
Give a very brief answer. 0.98. What is the ratio of the CO2 emissions (% of total fuel combustion) of Switzerland in 2005 to that in 2006?
Offer a terse response. 0.98. What is the ratio of the CO2 emissions (% of total fuel combustion) in East Asia (developing only) in 2005 to that in 2007?
Give a very brief answer. 1.03. What is the ratio of the CO2 emissions (% of total fuel combustion) in Hong Kong in 2005 to that in 2007?
Offer a very short reply. 1.21. What is the ratio of the CO2 emissions (% of total fuel combustion) in Lebanon in 2005 to that in 2007?
Offer a terse response. 1.09. What is the ratio of the CO2 emissions (% of total fuel combustion) in Switzerland in 2005 to that in 2007?
Keep it short and to the point. 0.92. What is the ratio of the CO2 emissions (% of total fuel combustion) in Hong Kong in 2006 to that in 2007?
Give a very brief answer. 1.05. What is the ratio of the CO2 emissions (% of total fuel combustion) in Lebanon in 2006 to that in 2007?
Your response must be concise. 1.12. What is the ratio of the CO2 emissions (% of total fuel combustion) in Switzerland in 2006 to that in 2007?
Make the answer very short. 0.94. What is the difference between the highest and the second highest CO2 emissions (% of total fuel combustion) in East Asia (developing only)?
Give a very brief answer. 0.59. What is the difference between the highest and the second highest CO2 emissions (% of total fuel combustion) in Hong Kong?
Give a very brief answer. 1.73. What is the difference between the highest and the second highest CO2 emissions (% of total fuel combustion) of Lebanon?
Offer a terse response. 0.58. What is the difference between the highest and the second highest CO2 emissions (% of total fuel combustion) in Switzerland?
Ensure brevity in your answer.  2.01. What is the difference between the highest and the lowest CO2 emissions (% of total fuel combustion) in East Asia (developing only)?
Offer a terse response. 1.62. What is the difference between the highest and the lowest CO2 emissions (% of total fuel combustion) in Hong Kong?
Your answer should be compact. 7.64. What is the difference between the highest and the lowest CO2 emissions (% of total fuel combustion) in Lebanon?
Your response must be concise. 3.97. What is the difference between the highest and the lowest CO2 emissions (% of total fuel combustion) of Switzerland?
Your response must be concise. 3.15. 